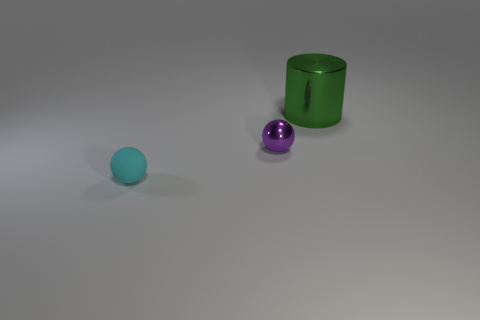How many brown things are either balls or metal objects?
Your answer should be compact. 0. There is a purple sphere that is the same size as the cyan rubber object; what is its material?
Offer a terse response. Metal. What shape is the thing that is both in front of the large green cylinder and on the right side of the cyan matte sphere?
Your answer should be very brief. Sphere. There is another ball that is the same size as the purple metallic sphere; what color is it?
Offer a terse response. Cyan. There is a shiny object that is right of the purple sphere; does it have the same size as the sphere that is to the left of the small purple shiny sphere?
Ensure brevity in your answer.  No. There is a metallic thing that is right of the tiny sphere behind the tiny thing in front of the tiny metal sphere; how big is it?
Give a very brief answer. Large. What is the shape of the matte thing on the left side of the tiny ball that is behind the small cyan thing?
Your answer should be very brief. Sphere. What is the color of the thing that is both behind the small cyan thing and to the left of the large green metal cylinder?
Provide a succinct answer. Purple. Is there a large object that has the same material as the small purple object?
Ensure brevity in your answer.  Yes. The green cylinder is what size?
Offer a terse response. Large. 